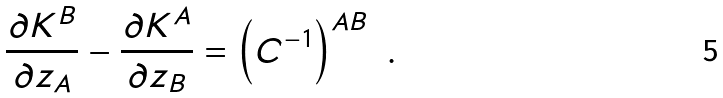<formula> <loc_0><loc_0><loc_500><loc_500>\frac { \partial K ^ { B } } { \partial z _ { A } } - \frac { \partial K ^ { A } } { \partial z _ { B } } = \left ( C ^ { - 1 } \right ) ^ { A B } \ .</formula> 